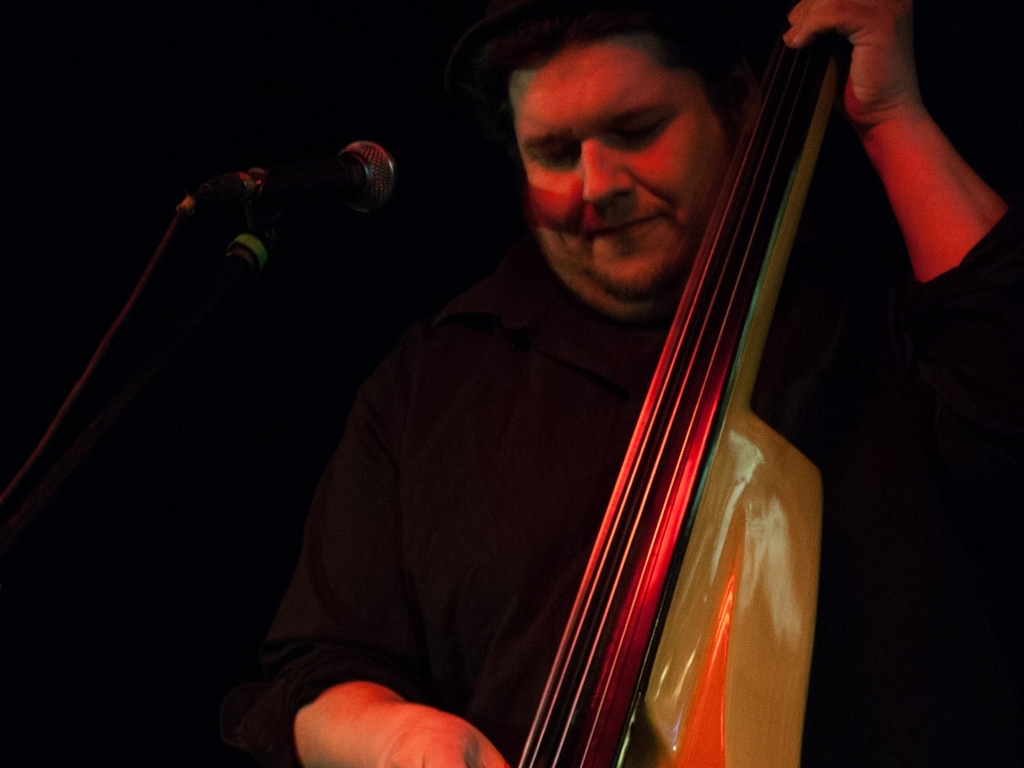What is the quality of this image?
A. Excellent
B. Good
C. Poor
D. Average The quality of the image appears to be average, which corresponds to option D. The image is somewhat dark and lacks sharpness, which diminishes the detail that can be seen. The subject – a person playing a double bass – is clear, but improving the lighting and focus would enhance the overall image quality. 